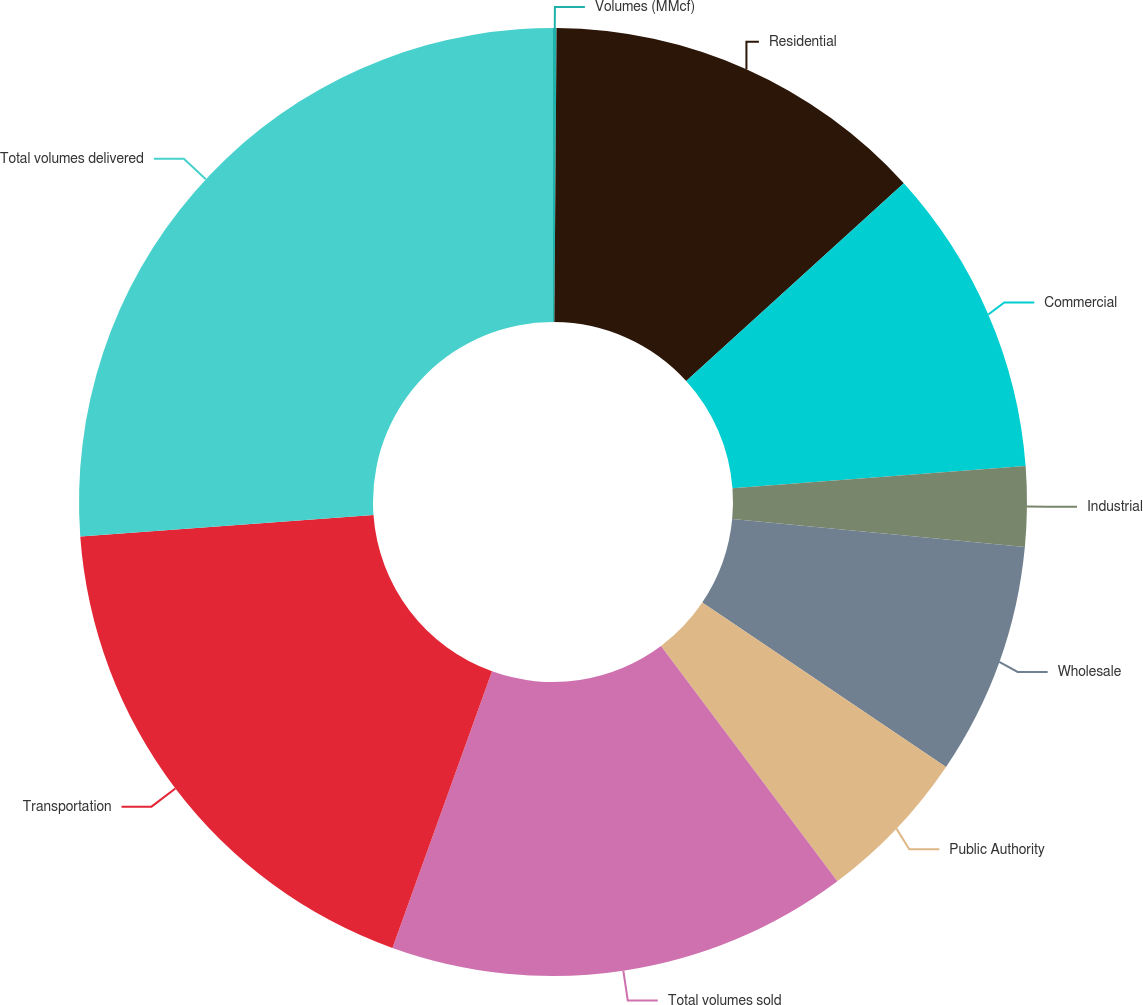Convert chart. <chart><loc_0><loc_0><loc_500><loc_500><pie_chart><fcel>Volumes (MMcf)<fcel>Residential<fcel>Commercial<fcel>Industrial<fcel>Wholesale<fcel>Public Authority<fcel>Total volumes sold<fcel>Transportation<fcel>Total volumes delivered<nl><fcel>0.12%<fcel>13.14%<fcel>10.53%<fcel>2.72%<fcel>7.93%<fcel>5.32%<fcel>15.74%<fcel>18.34%<fcel>26.16%<nl></chart> 